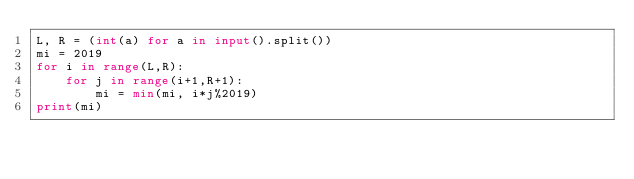Convert code to text. <code><loc_0><loc_0><loc_500><loc_500><_Python_>L, R = (int(a) for a in input().split())
mi = 2019
for i in range(L,R):
    for j in range(i+1,R+1):
        mi = min(mi, i*j%2019)
print(mi)</code> 